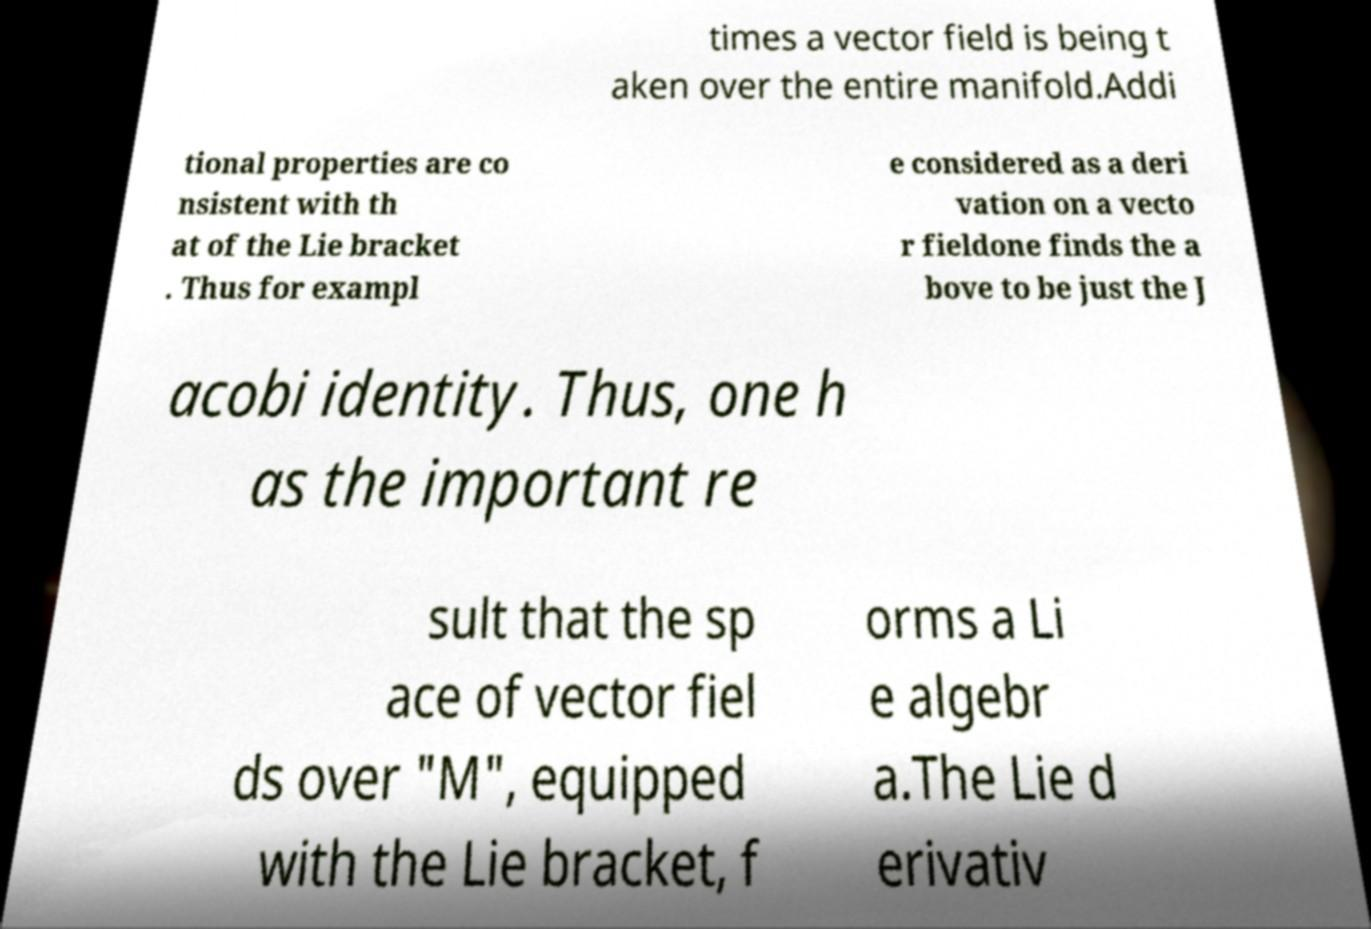There's text embedded in this image that I need extracted. Can you transcribe it verbatim? times a vector field is being t aken over the entire manifold.Addi tional properties are co nsistent with th at of the Lie bracket . Thus for exampl e considered as a deri vation on a vecto r fieldone finds the a bove to be just the J acobi identity. Thus, one h as the important re sult that the sp ace of vector fiel ds over "M", equipped with the Lie bracket, f orms a Li e algebr a.The Lie d erivativ 